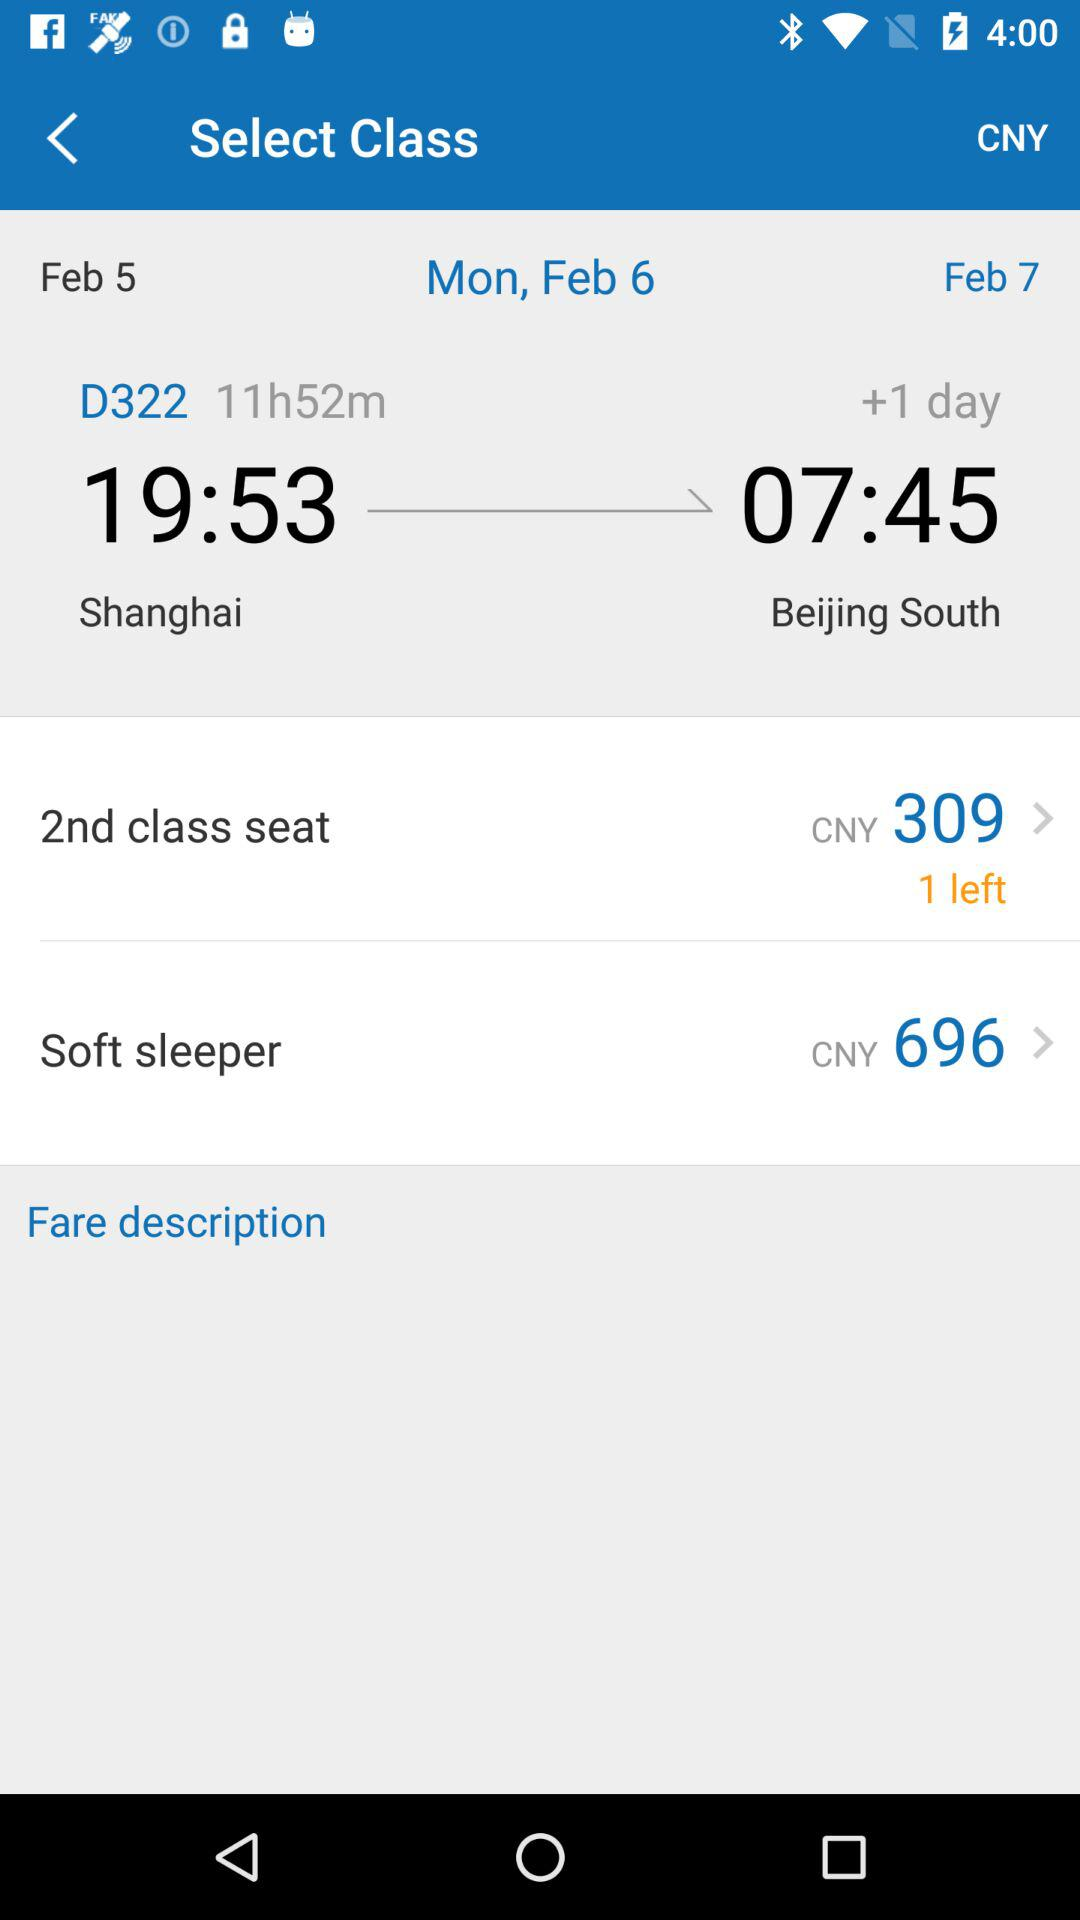What is the travel time from Shanghai to Beijing South? The travel time from Shanghai to Beijing South is 11 hours 52 minutes. 